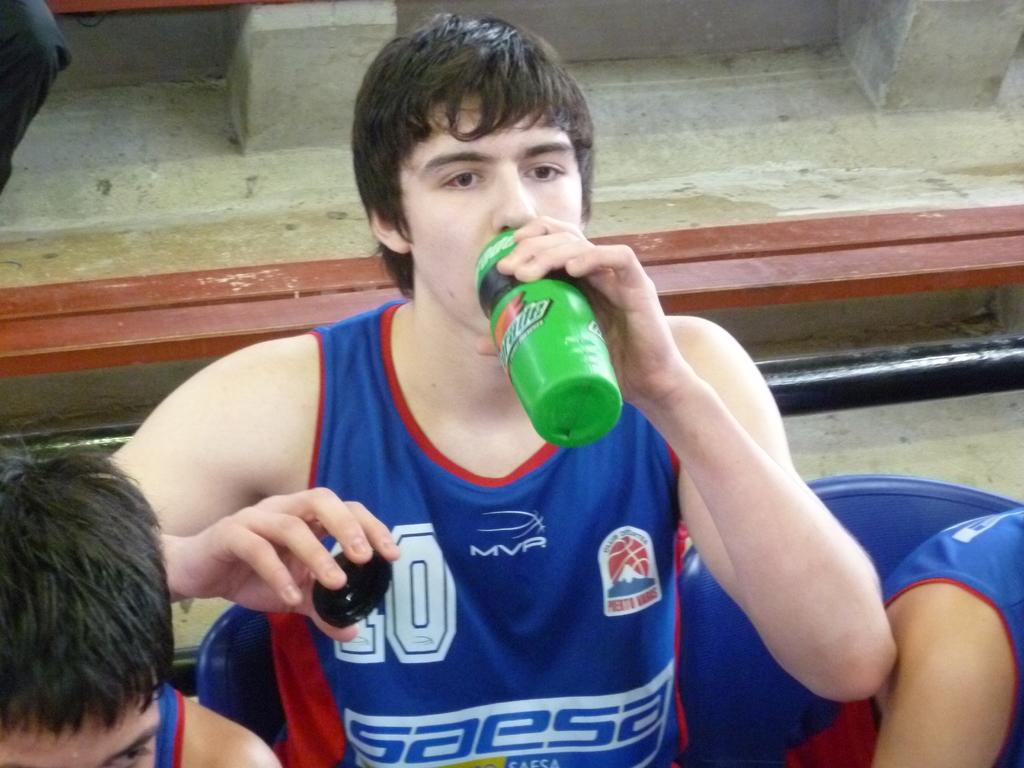<image>
Provide a brief description of the given image. A boy drinking from a green bottle, wearing a tee shirt with the word SAESA on it. 